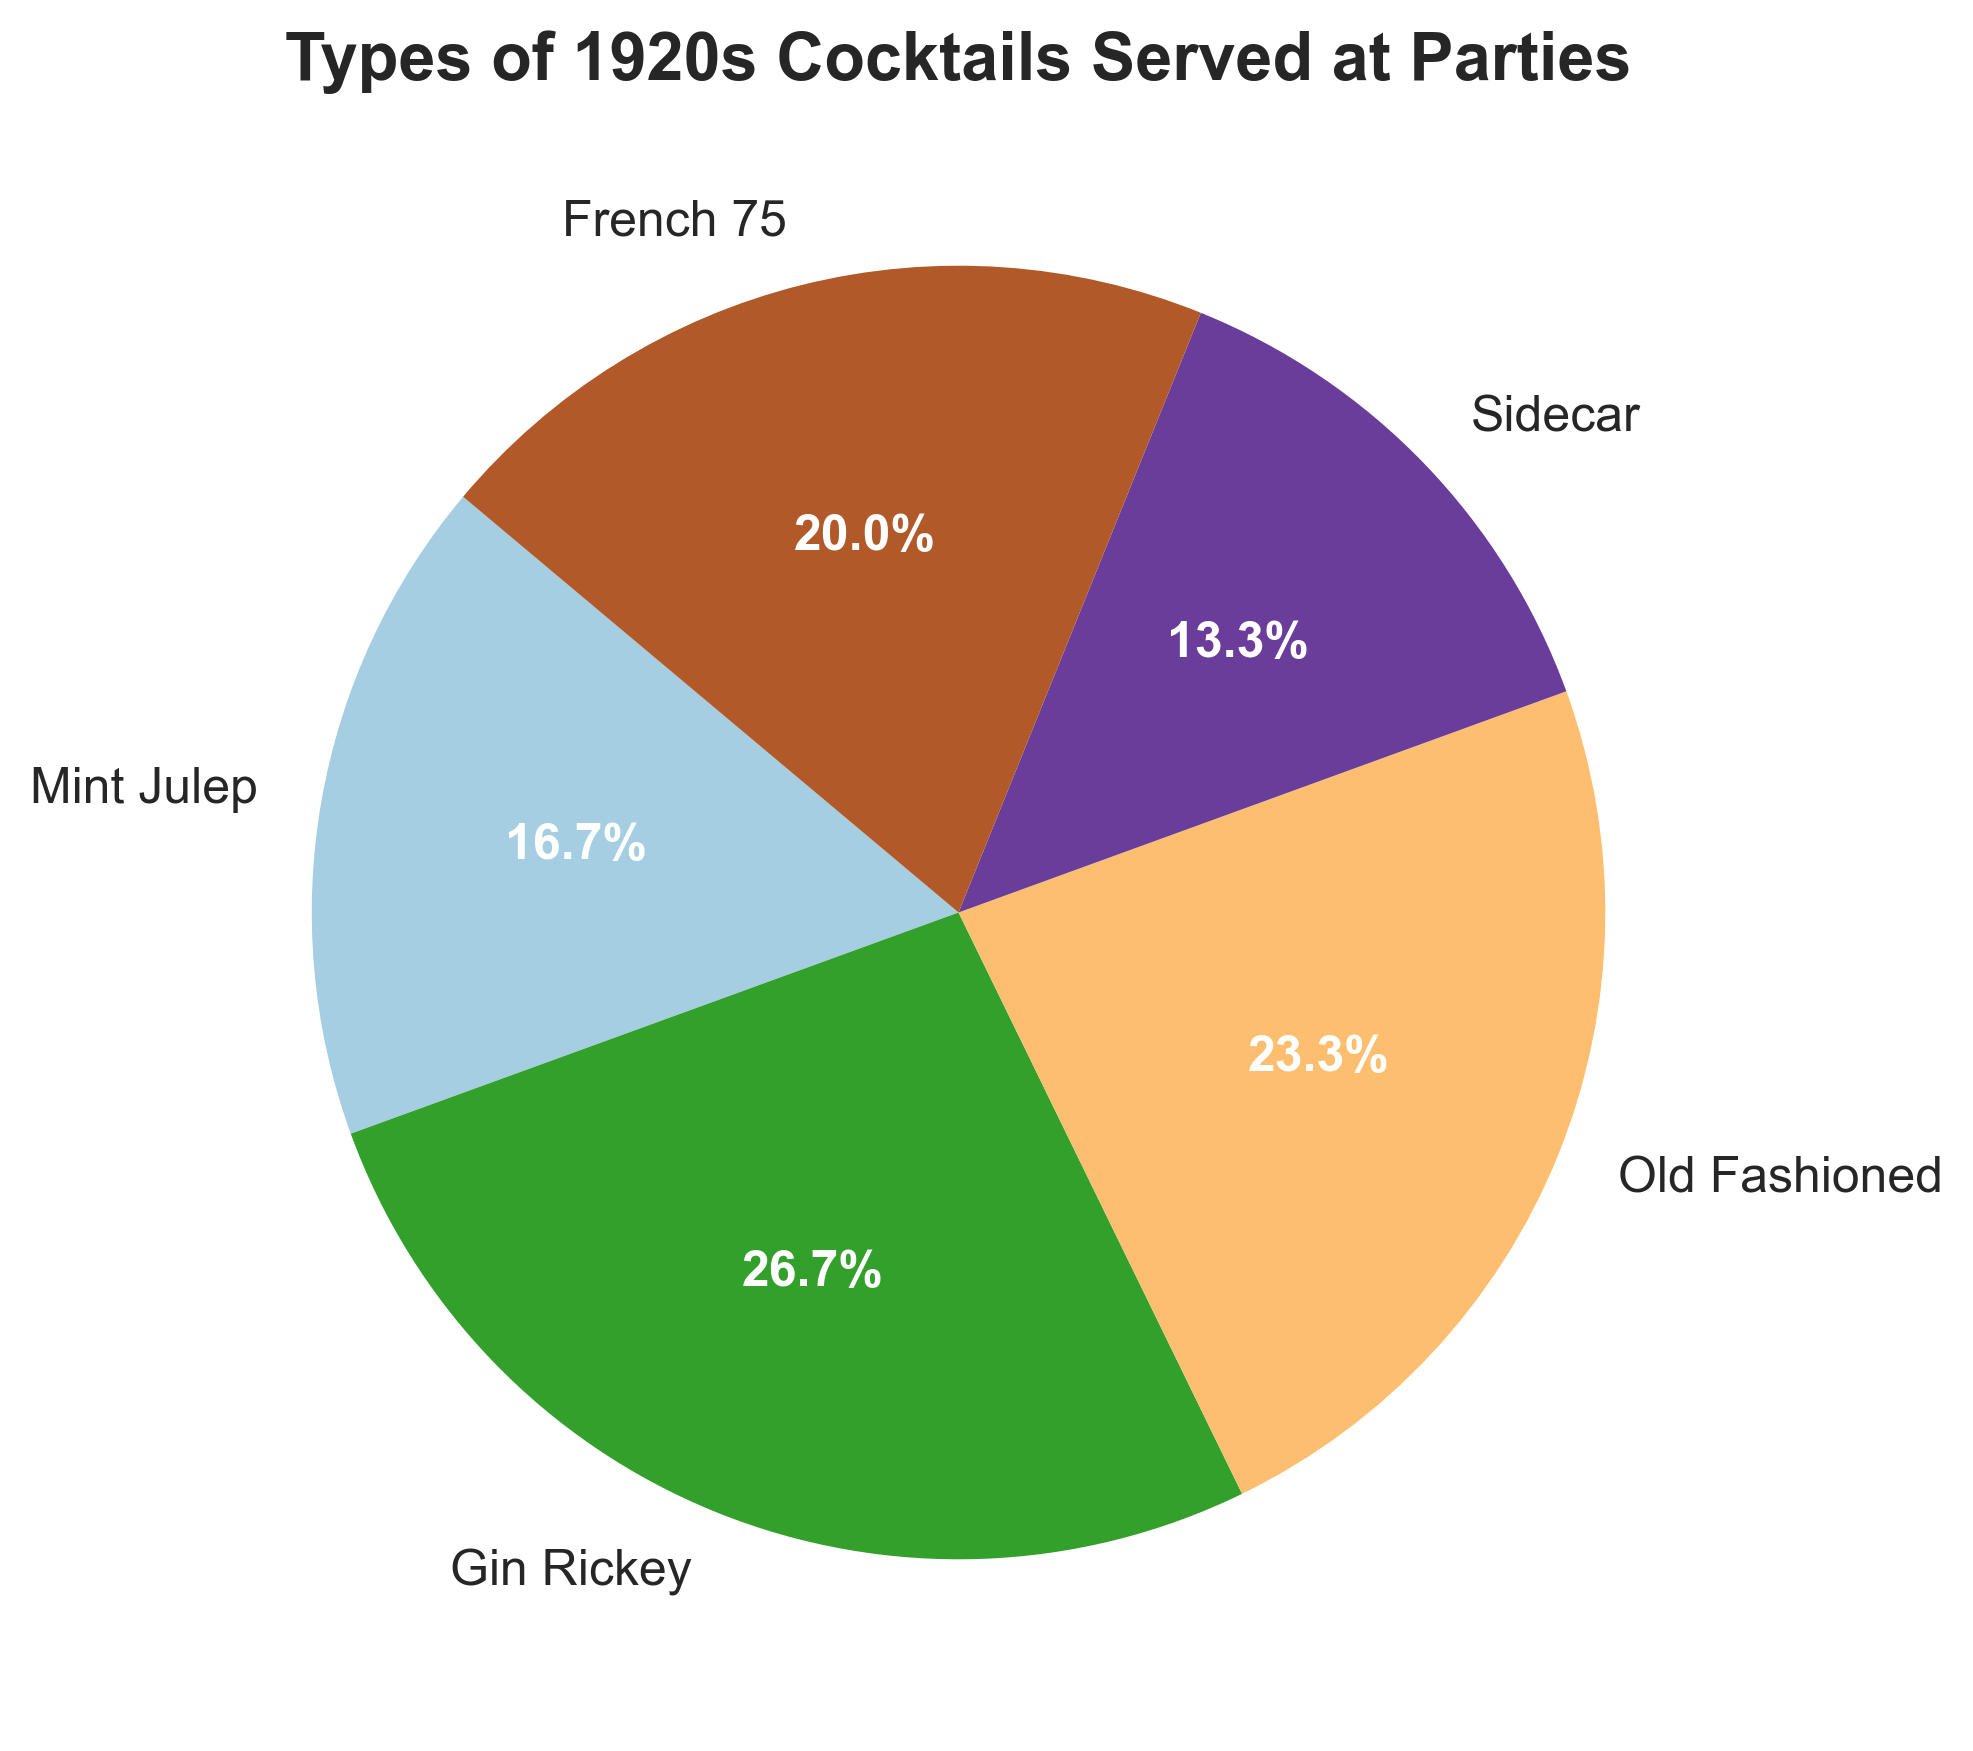What percentage of the total cocktails is Mint Julep? Mint Julep is represented by a slice of the pie chart. The corresponding percentage is displayed within the slice.
Answer: 18.9% Which cocktail has the highest number of servings? By comparing the sizes of each slice, the largest slice corresponds to Gin Rickey.
Answer: Gin Rickey How many more times was Gin Rickey served compared to Sidecar? Gin Rickey is served 40 times and Sidecar is served 20 times. The difference is 40 - 20 = 20.
Answer: 20 What is the total number of Old Fashioned and French 75 cocktails served? Sum the number of times Old Fashioned (35) and French 75 (30) were served: 35 + 30 = 65.
Answer: 65 Which two cocktails have the least difference in the number of servings? Comparing the data values, the smallest difference is between French 75 (30) and Old Fashioned (35). The difference is 35 - 30 = 5.
Answer: French 75 and Old Fashioned Add the number of servings for Mint Julep and Sidecar, what is the result? Sum the number of times Mint Julep (25) and Sidecar (20) were served: 25 + 20 = 45.
Answer: 45 If you combine the servings of Mint Julep, Old Fashioned, and French 75, what percentage of the total does this represent? First, sum their number of servings: 25 (Mint Julep) + 35 (Old Fashioned) + 30 (French 75) = 90. The total number of servings for all cocktails is 150. So, (90/150) * 100 = 60%.
Answer: 60% Which cocktail appears in the third largest slice of the pie chart? The third largest slice corresponds to the number of times served; Old Fashioned is third in number of servings (35).
Answer: Old Fashioned 